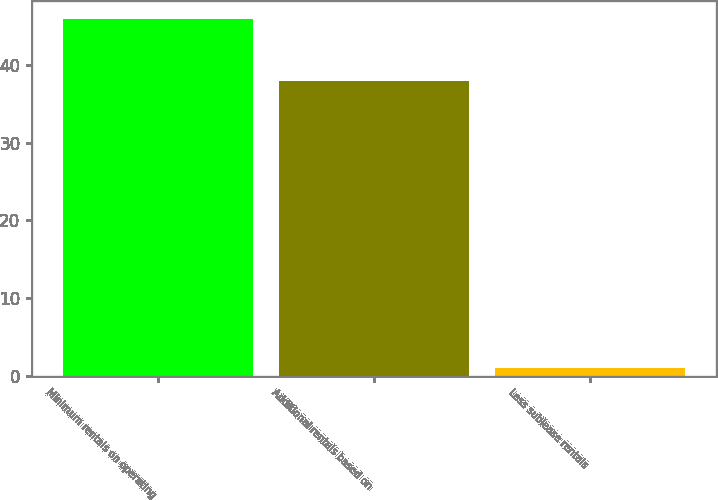Convert chart. <chart><loc_0><loc_0><loc_500><loc_500><bar_chart><fcel>Minimum rentals on operating<fcel>Additional rentals based on<fcel>Less sublease rentals<nl><fcel>46<fcel>38<fcel>1<nl></chart> 